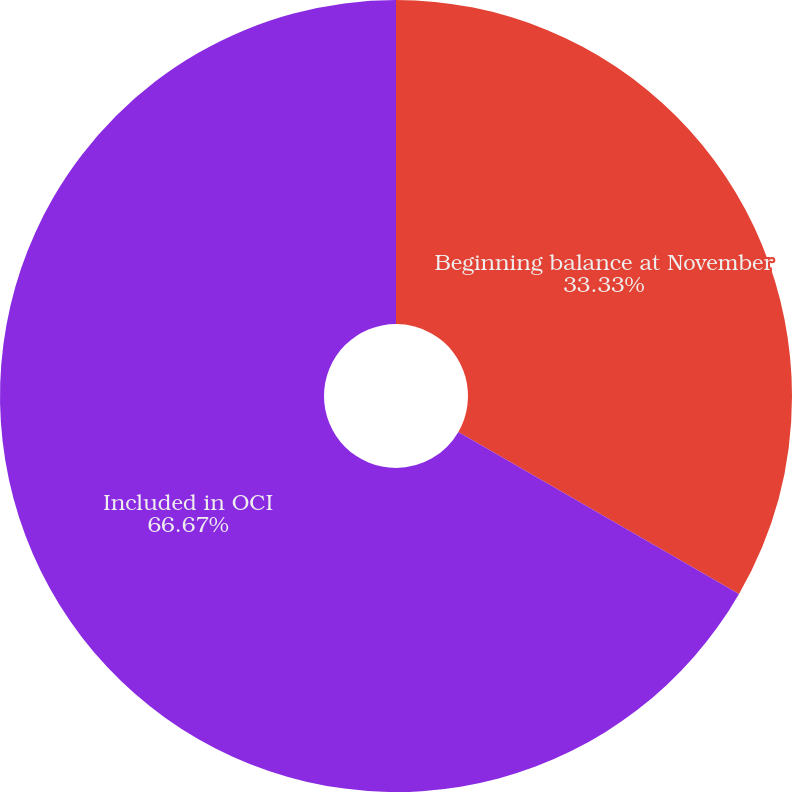Convert chart to OTSL. <chart><loc_0><loc_0><loc_500><loc_500><pie_chart><fcel>Beginning balance at November<fcel>Included in OCI<nl><fcel>33.33%<fcel>66.67%<nl></chart> 